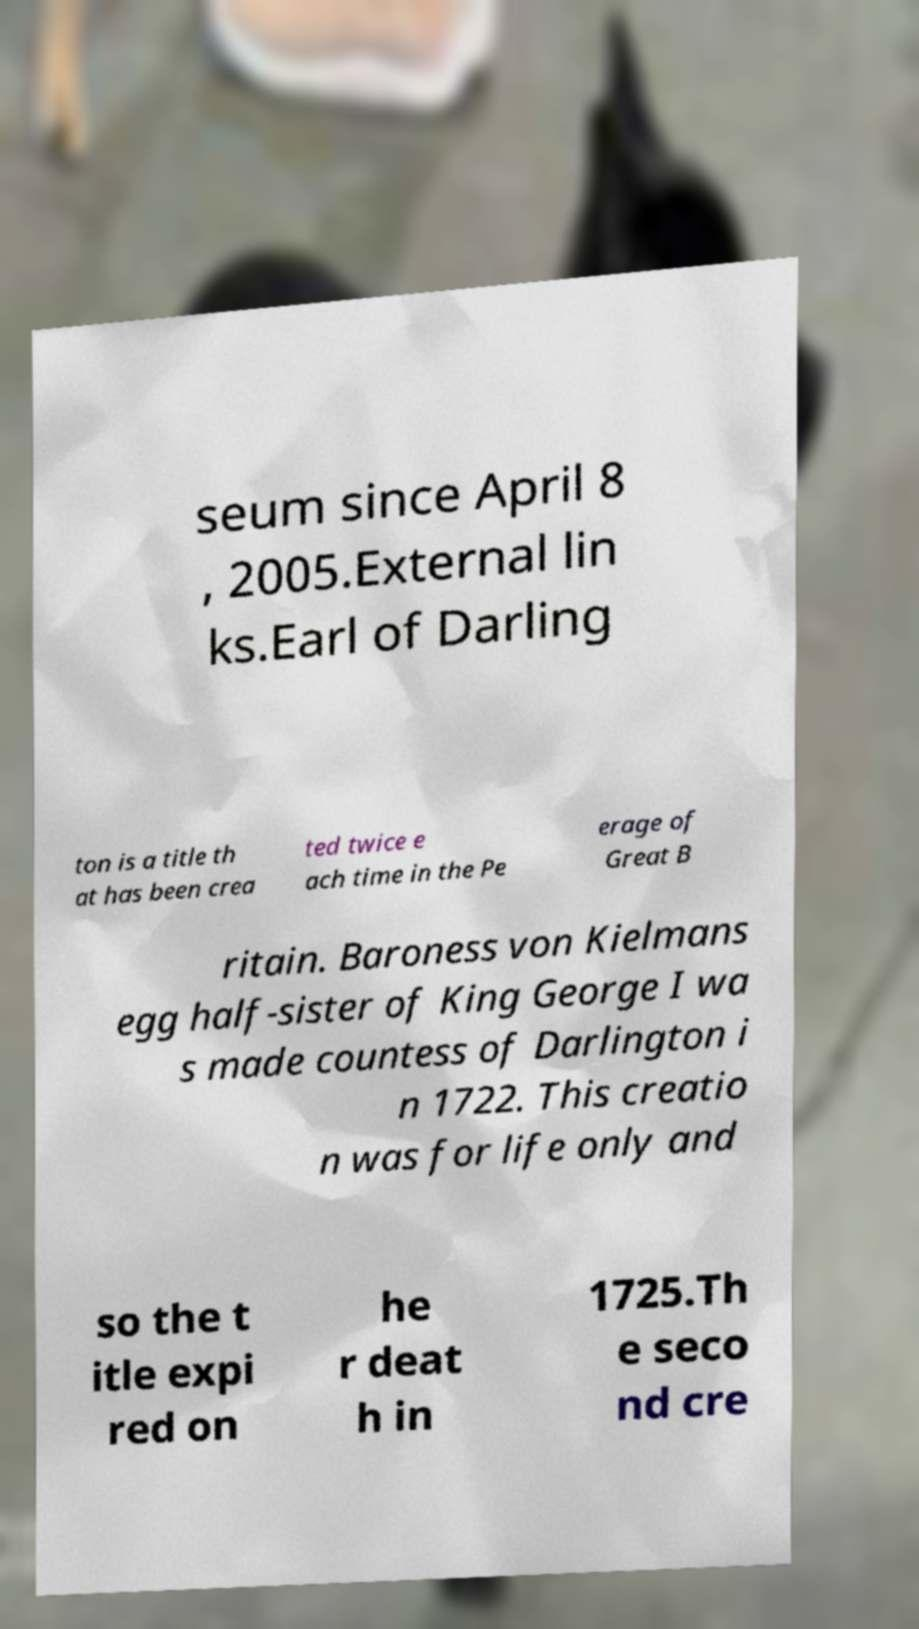Could you assist in decoding the text presented in this image and type it out clearly? seum since April 8 , 2005.External lin ks.Earl of Darling ton is a title th at has been crea ted twice e ach time in the Pe erage of Great B ritain. Baroness von Kielmans egg half-sister of King George I wa s made countess of Darlington i n 1722. This creatio n was for life only and so the t itle expi red on he r deat h in 1725.Th e seco nd cre 